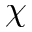Convert formula to latex. <formula><loc_0><loc_0><loc_500><loc_500>\chi</formula> 